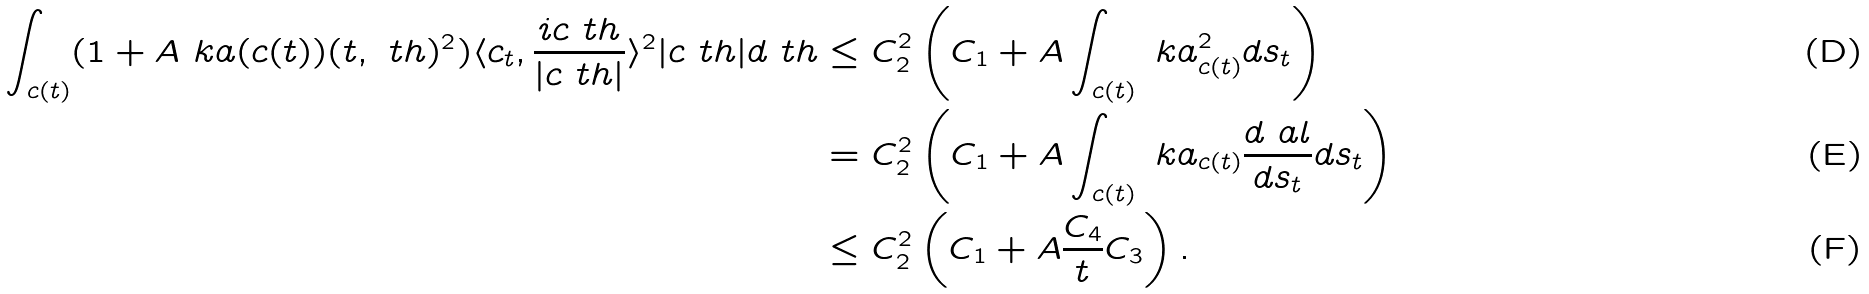<formula> <loc_0><loc_0><loc_500><loc_500>\int _ { c ( t ) } ( 1 + A \ k a ( c ( t ) ) ( t , \ t h ) ^ { 2 } ) \langle c _ { t } , \frac { i c _ { \ } t h } { | c _ { \ } t h | } \rangle ^ { 2 } | c _ { \ } t h | d \ t h & \leq C _ { 2 } ^ { 2 } \left ( C _ { 1 } + A \int _ { c ( t ) } \ k a _ { c ( t ) } ^ { 2 } d s _ { t } \right ) \\ & = C _ { 2 } ^ { 2 } \left ( C _ { 1 } + A \int _ { c ( t ) } \ k a _ { c ( t ) } \frac { d \ a l } { d s _ { t } } d s _ { t } \right ) \\ & \leq C _ { 2 } ^ { 2 } \left ( C _ { 1 } + A \frac { C _ { 4 } } { t } C _ { 3 } \right ) .</formula> 